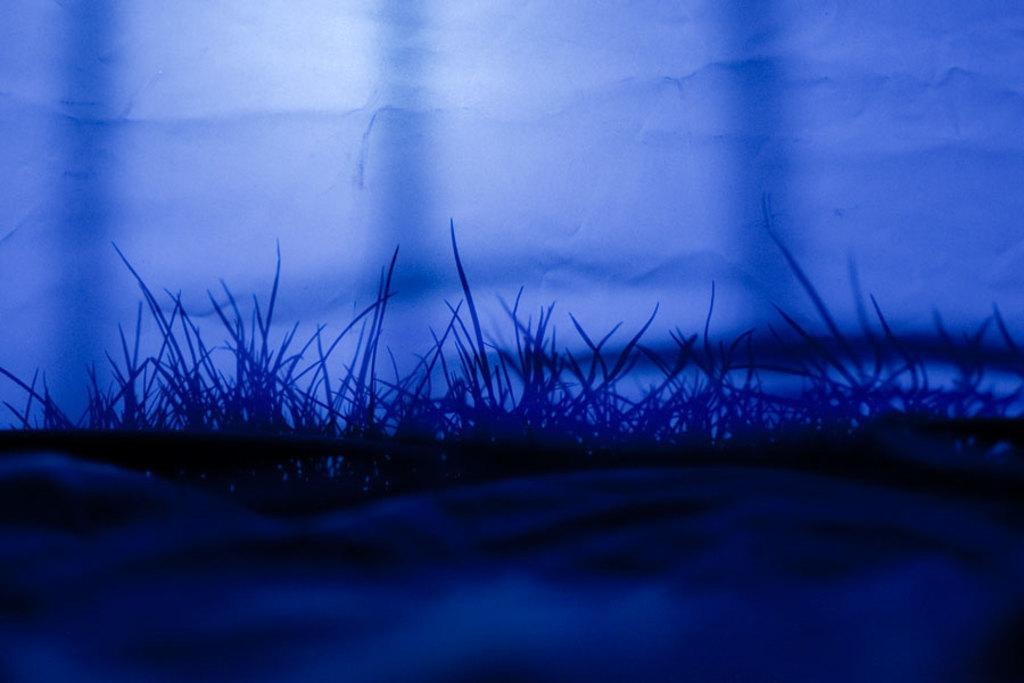Could you give a brief overview of what you see in this image? In this image we can see grass. Near to the grass there is a wall with shadow of grass. And the image is dark. 